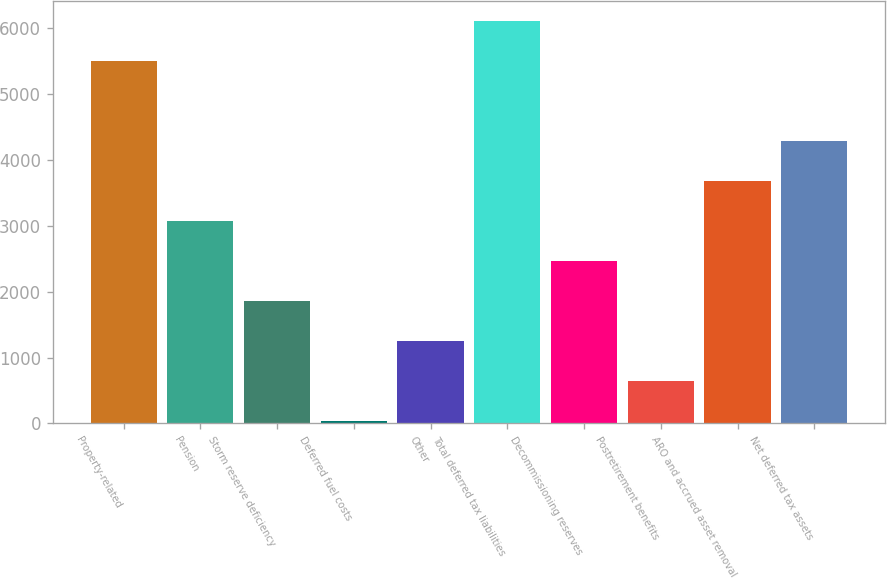<chart> <loc_0><loc_0><loc_500><loc_500><bar_chart><fcel>Property-related<fcel>Pension<fcel>Storm reserve deficiency<fcel>Deferred fuel costs<fcel>Other<fcel>Total deferred tax liabilities<fcel>Decommissioning reserves<fcel>Postretirement benefits<fcel>ARO and accrued asset removal<fcel>Net deferred tax assets<nl><fcel>5499.4<fcel>3073<fcel>1859.8<fcel>40<fcel>1253.2<fcel>6106<fcel>2466.4<fcel>646.6<fcel>3679.6<fcel>4286.2<nl></chart> 